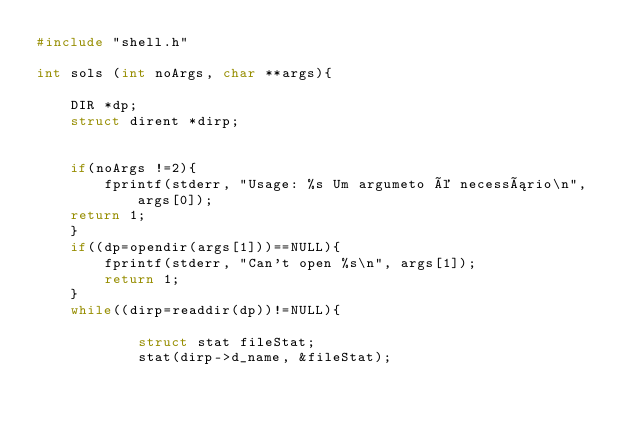<code> <loc_0><loc_0><loc_500><loc_500><_C_>#include "shell.h"

int sols (int noArgs, char **args){

    DIR *dp;
    struct dirent *dirp;

    
    if(noArgs !=2){
        fprintf(stderr, "Usage: %s Um argumeto é necessário\n", args[0]);
    return 1;
    }
    if((dp=opendir(args[1]))==NULL){
        fprintf(stderr, "Can't open %s\n", args[1]);
        return 1;
    }
    while((dirp=readdir(dp))!=NULL){
        
            struct stat fileStat;
            stat(dirp->d_name, &fileStat);
        </code> 